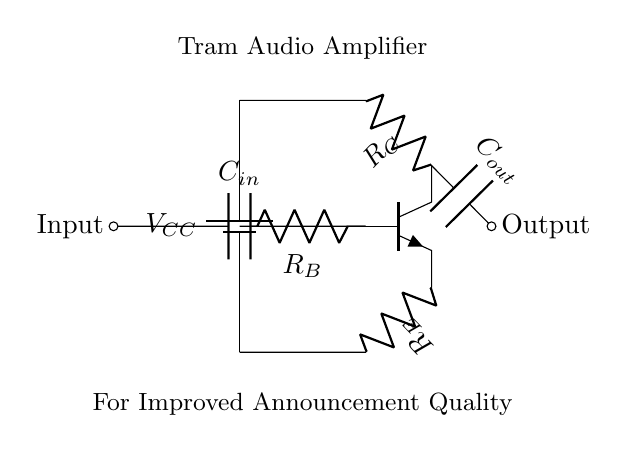What type of transistor is used in this circuit? The circuit diagram shows an NPN transistor, indicated by the symbol used in the diagram.
Answer: NPN What is the purpose of capacitor C in? The capacitor C in is used to block any DC component from the input signal, allowing only AC signals (audio) to pass through to the base of the transistor.
Answer: Block DC What is the main function of resistor R_E? Resistor R_E is used to provide stability to the biasing of the transistor and to set the emitter current.
Answer: Set emitter current How many resistors are present in the circuit? The circuit diagram displays three resistors (R_C, R_B, R_E) as part of the transistor amplifier setup.
Answer: Three What does C_out do in the circuit? C_out serves to block the DC voltage at the collector while allowing the amplified AC audio signal to be output.
Answer: Block DC What is the relationship between the input and output of the amplifier? The input signal is amplified at the output, meaning the output signal's amplitude is greater than that of the input signal, indicative of an amplification function.
Answer: Amplification What does the power supply voltage V_CC represent? V_CC is the supply voltage for the circuit, typically providing the necessary power to the transistor for operation and amplification of the audio signal.
Answer: Supply voltage 